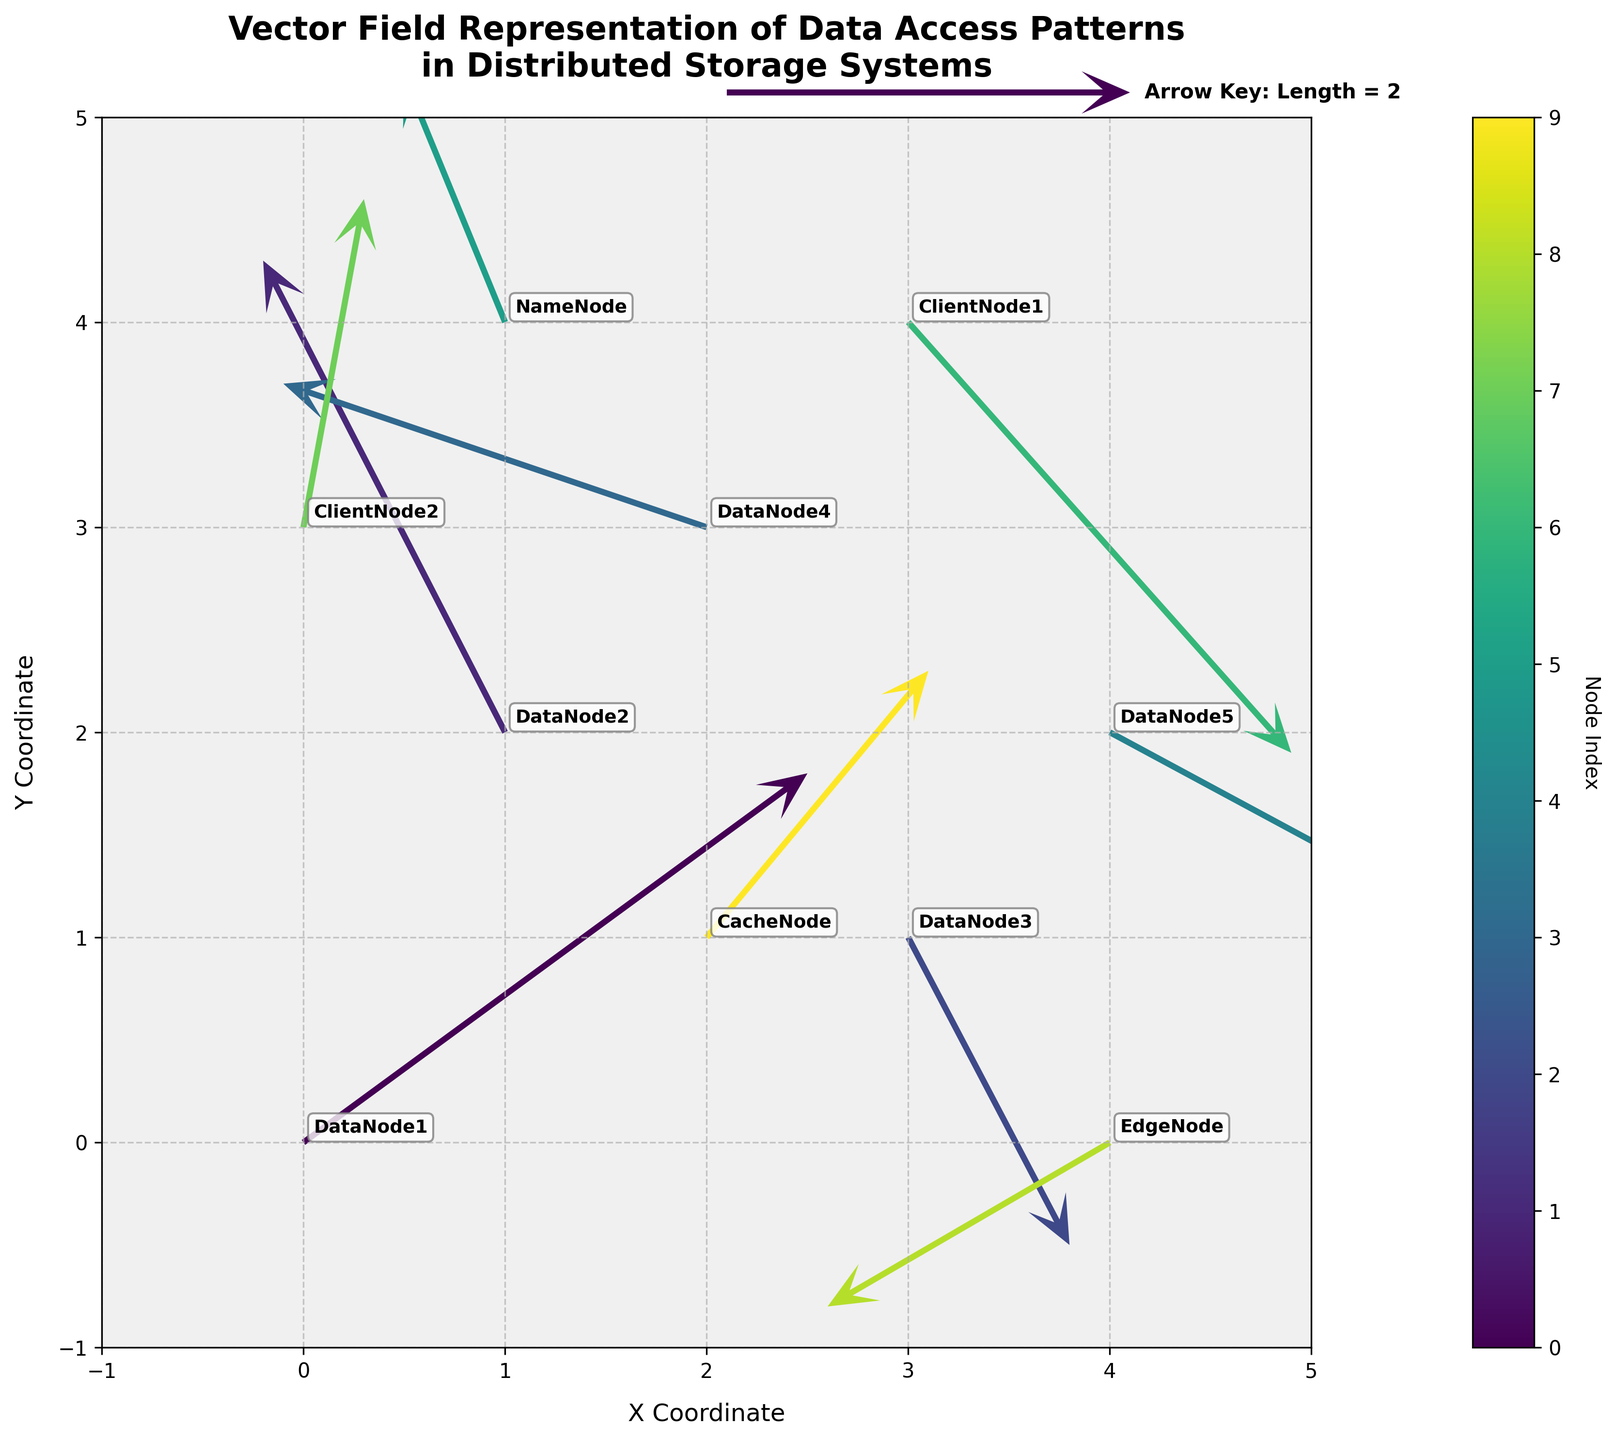How many nodes are represented in the plot? Count the number of unique nodes in the annotations. There are 10 rows, each representing a different node.
Answer: 10 Which node shows the longest vector magnitude? Calculate the magnitude for each node using the formula √(U^2 + V^2) and compare. The node with coordinates (0, 0) with vector (2.5, 1.8) has the highest magnitude √(2.5^2 + 1.8^2) ≈ 3.0.
Answer: DataNode1 What is the primary direction of data access from CacheNode? Check the vector direction starting at (2, 1). The vector (1.1, 1.3) mainly points northeast.
Answer: Northeast Are there any nodes with data access vectors pointing directly downwards? Look for vectors with U ~ 0 and V < 0. None of the vectors point directly downward.
Answer: No Which node is positioned furthest to the right on the plot? Identify the node with the highest X value. The node with X=4, Y=0 is EdgeNode.
Answer: EdgeNode What is the sum of all X-components (U values) in the plot? Sum all the U values: 2.5 - 1.2 + 0.8 - 2.1 + 1.7 - 0.5 + 1.9 + 0.3 - 1.4 + 1.1. The total is 3.1.
Answer: 3.1 Which node has the smallest vector magnitude? Calculate the magnitude for each node and find the smallest. Magnitude for ClientNode2 with vector (0.3, 1.6) is ~1.63, which is the smallest.
Answer: ClientNode2 Do more nodes have vectors pointing upwards or downwards? Count vectors where V > 0 (upwards) and V < 0 (downwards). There are 6 upwards and 4 downwards, so more point upwards.
Answer: Upwards Which node has the highest Y coordinate value? The node with the highest Y value is named the NameNode with Y=4.
Answer: NameNode Is there any significant clustering of nodes in a specific area of the plot? Look for areas with higher density of nodes. Nodes seem evenly distributed without significant clustering.
Answer: No 